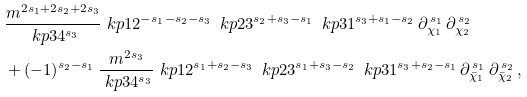<formula> <loc_0><loc_0><loc_500><loc_500>& \frac { m ^ { 2 s _ { 1 } + 2 s _ { 2 } + 2 s _ { 3 } } } { \ k p 3 4 ^ { s _ { 3 } } } \ k p 1 2 ^ { - s _ { 1 } - s _ { 2 } - s _ { 3 } } \, \ k p 2 3 ^ { s _ { 2 } + s _ { 3 } - s _ { 1 } } \, \ k p 3 1 ^ { s _ { 3 } + s _ { 1 } - s _ { 2 } } \, \partial _ { \chi _ { 1 } } ^ { \, s _ { 1 } } \, \partial _ { \chi _ { 2 } } ^ { \, s _ { 2 } } \\ & + ( - 1 ) ^ { s _ { 2 } - s _ { 1 } } \, \frac { m ^ { 2 s _ { 3 } } } { \ k p 3 4 ^ { s _ { 3 } } } \ k p 1 2 ^ { s _ { 1 } + s _ { 2 } - s _ { 3 } } \, \ k p 2 3 ^ { s _ { 1 } + s _ { 3 } - s _ { 2 } } \, \ k p 3 1 ^ { s _ { 3 } + s _ { 2 } - s _ { 1 } } \, \partial _ { \bar { \chi } _ { 1 } } ^ { \, s _ { 1 } } \, \partial _ { \bar { \chi } _ { 2 } } ^ { \, s _ { 2 } } \, ,</formula> 